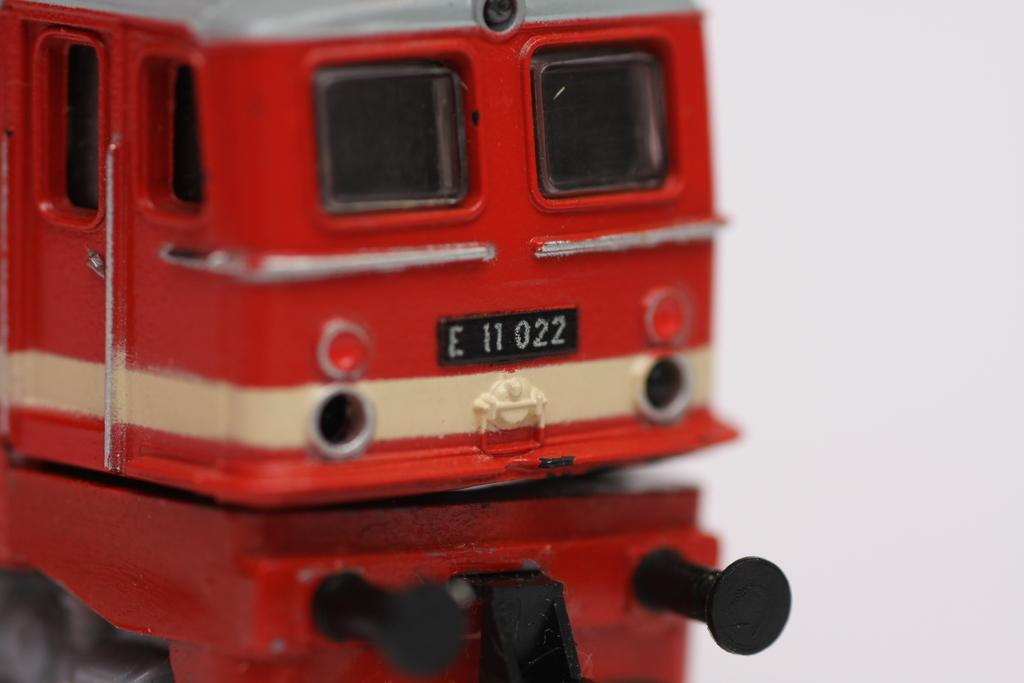<image>
Share a concise interpretation of the image provided. The rear end of train or subway with a black E11022 license plate. 